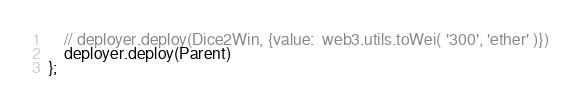Convert code to text. <code><loc_0><loc_0><loc_500><loc_500><_JavaScript_>    // deployer.deploy(Dice2Win, {value:  web3.utils.toWei( '300', 'ether' )})
    deployer.deploy(Parent)
};
</code> 